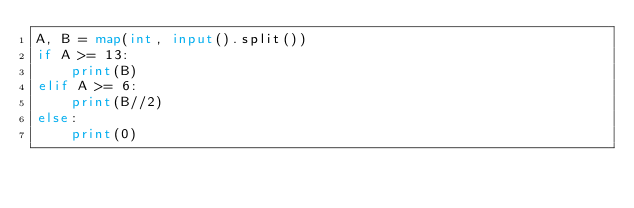<code> <loc_0><loc_0><loc_500><loc_500><_Python_>A, B = map(int, input().split())
if A >= 13:
    print(B)
elif A >= 6:
    print(B//2)
else:
    print(0)</code> 